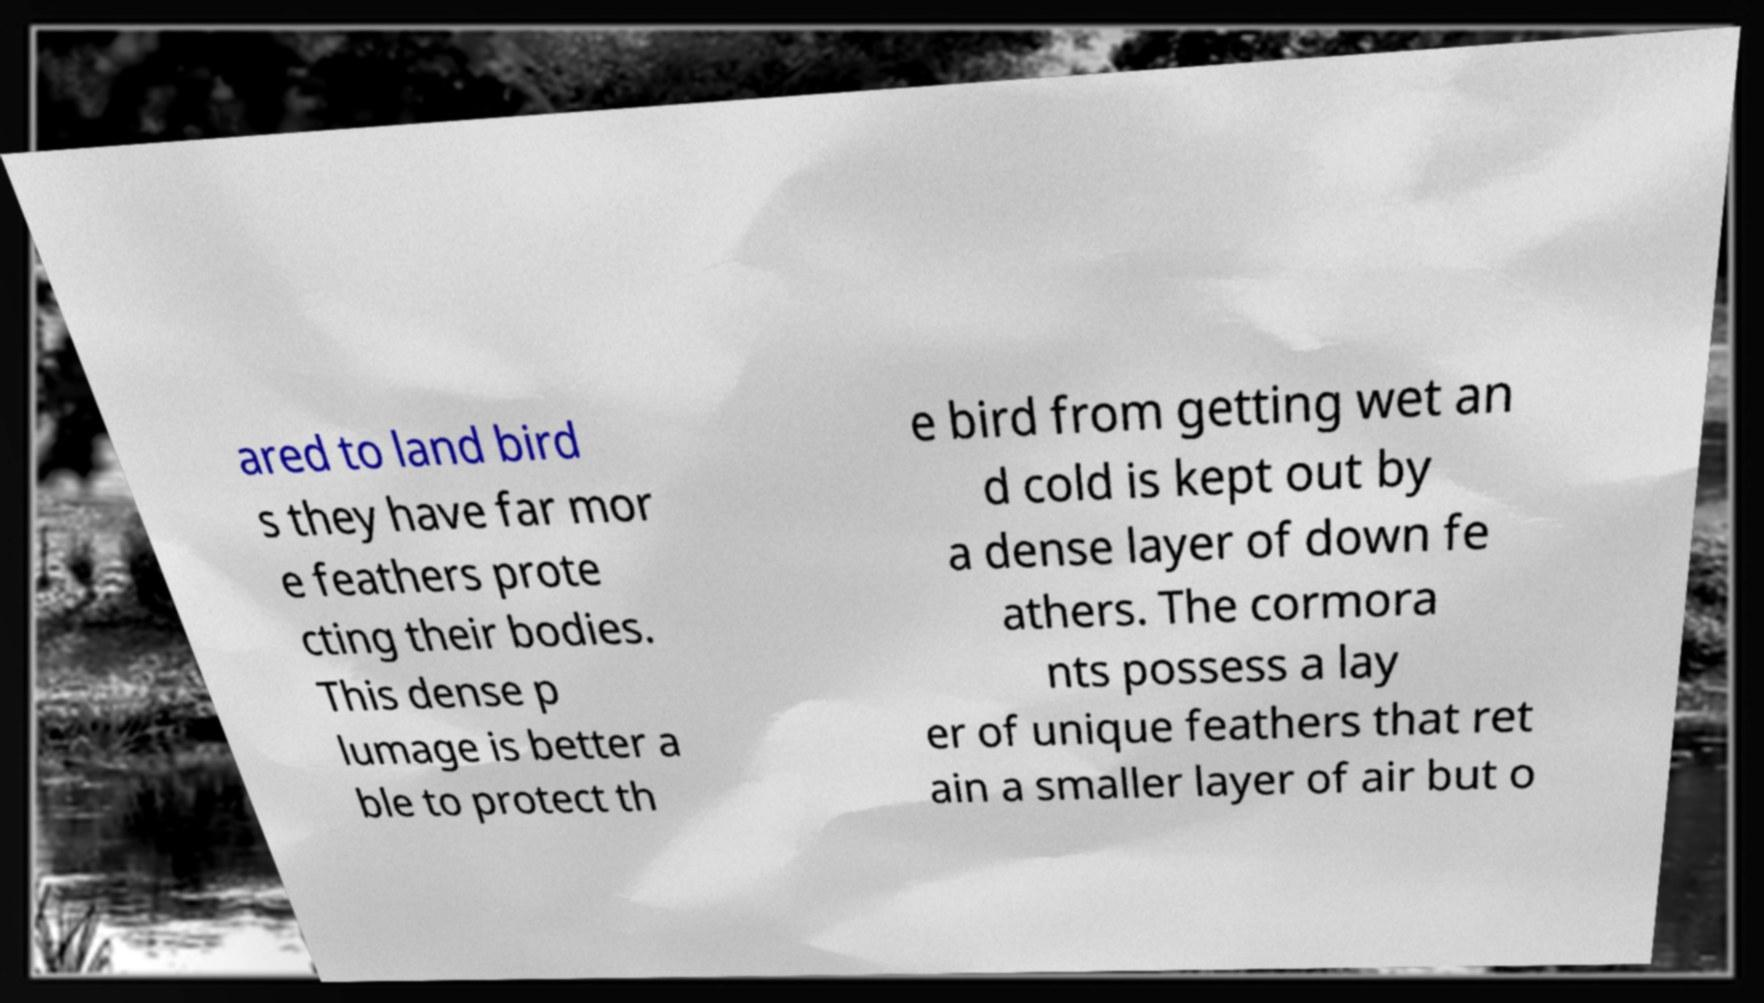Can you accurately transcribe the text from the provided image for me? ared to land bird s they have far mor e feathers prote cting their bodies. This dense p lumage is better a ble to protect th e bird from getting wet an d cold is kept out by a dense layer of down fe athers. The cormora nts possess a lay er of unique feathers that ret ain a smaller layer of air but o 